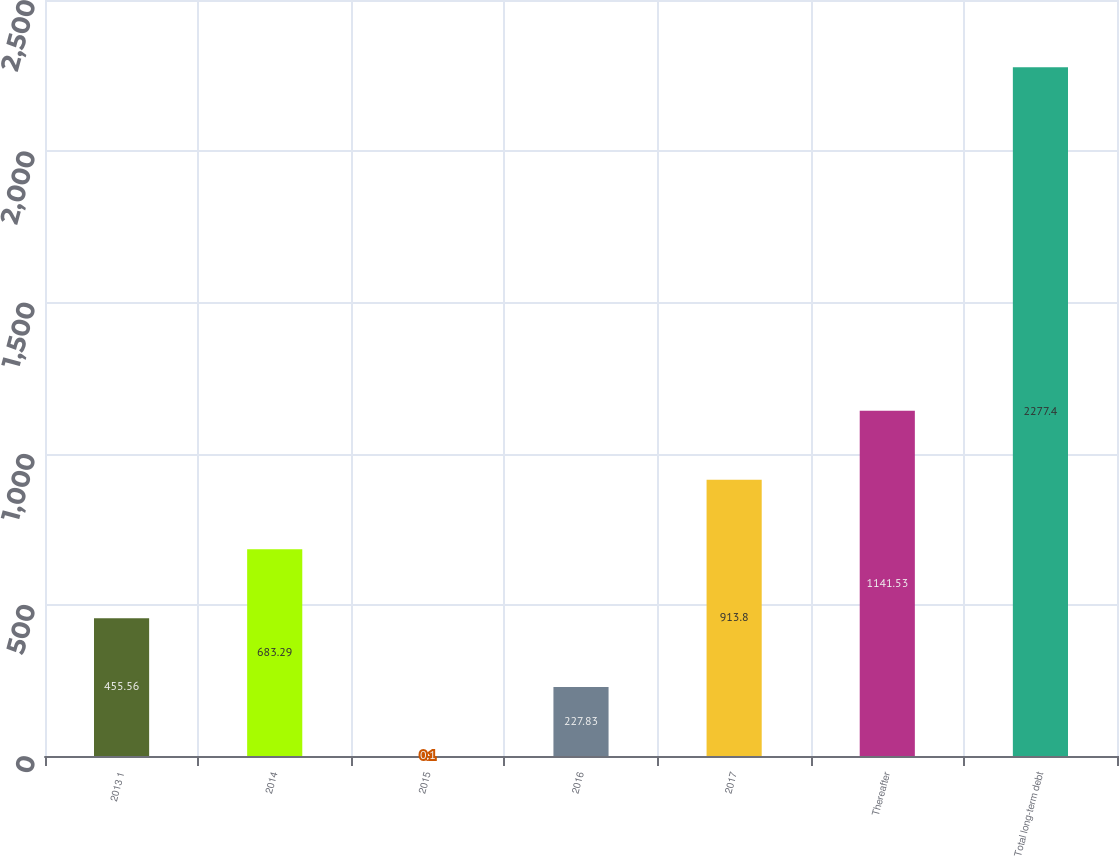<chart> <loc_0><loc_0><loc_500><loc_500><bar_chart><fcel>2013 1<fcel>2014<fcel>2015<fcel>2016<fcel>2017<fcel>Thereafter<fcel>Total long-term debt<nl><fcel>455.56<fcel>683.29<fcel>0.1<fcel>227.83<fcel>913.8<fcel>1141.53<fcel>2277.4<nl></chart> 